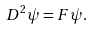<formula> <loc_0><loc_0><loc_500><loc_500>D ^ { 2 } \psi = F \psi .</formula> 